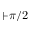<formula> <loc_0><loc_0><loc_500><loc_500>+ \pi / 2</formula> 